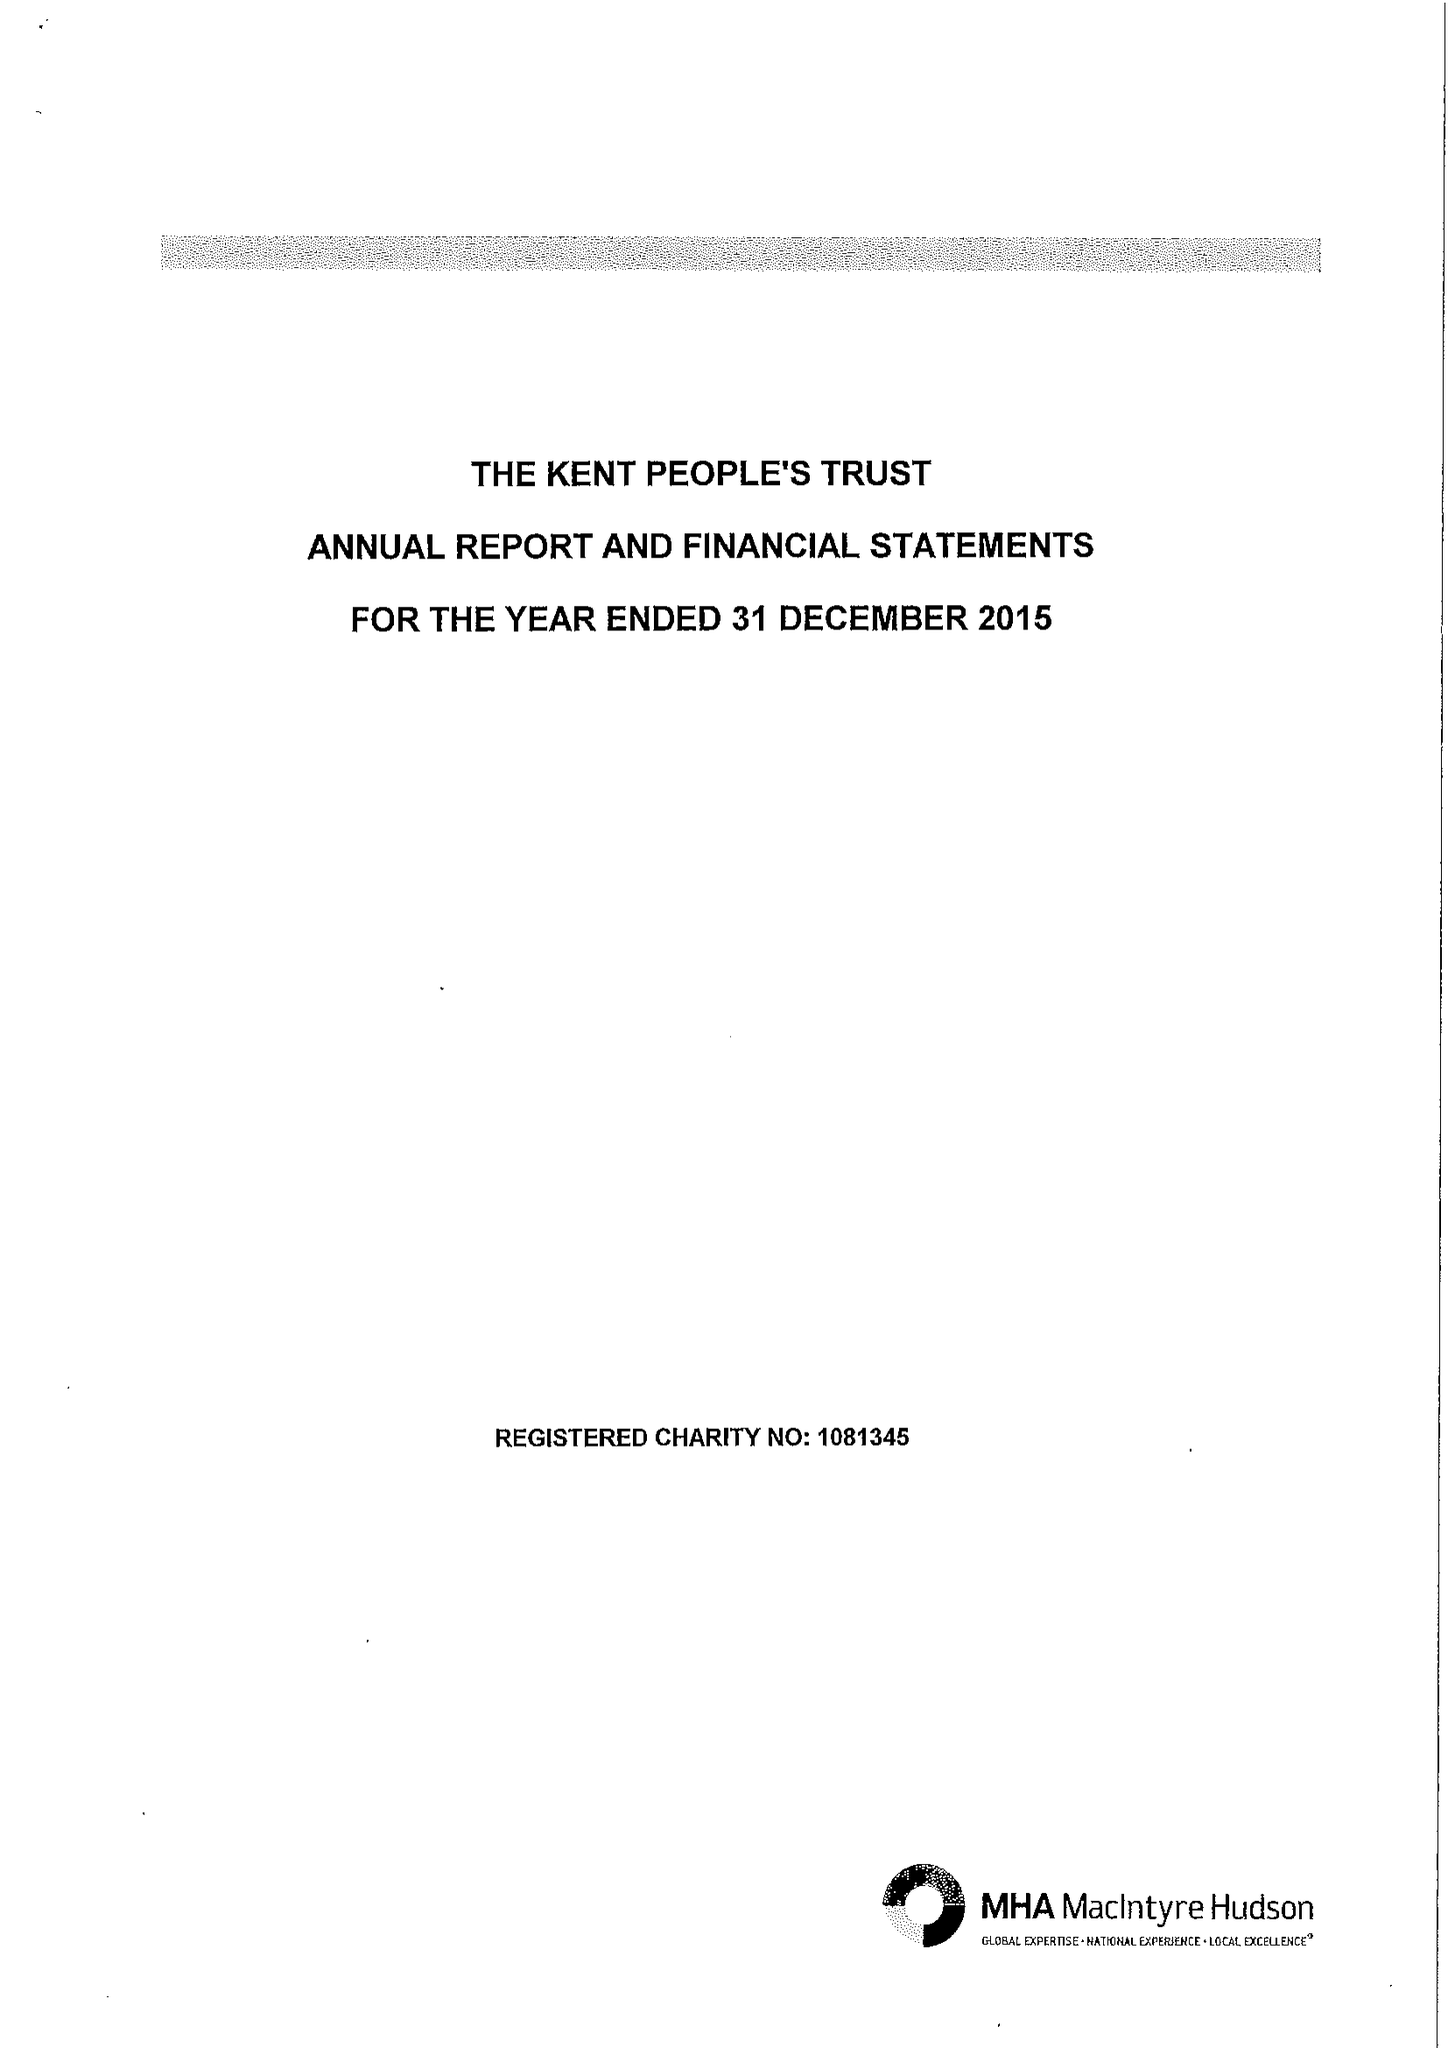What is the value for the charity_number?
Answer the question using a single word or phrase. 1081345 